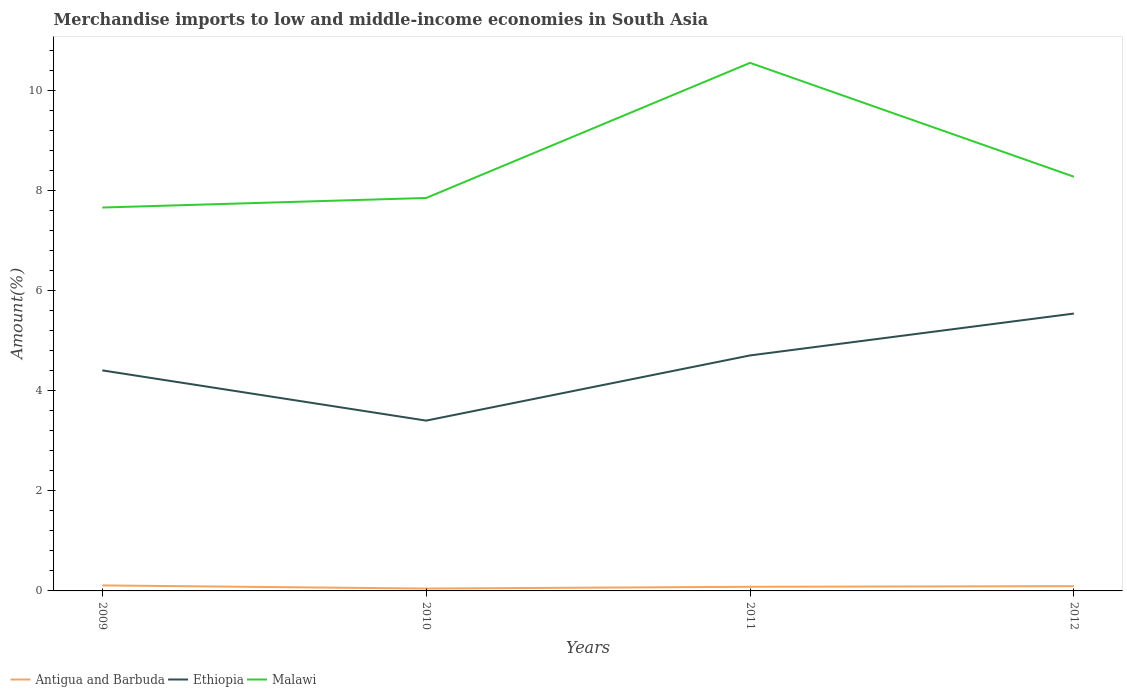How many different coloured lines are there?
Offer a very short reply. 3. Across all years, what is the maximum percentage of amount earned from merchandise imports in Ethiopia?
Your answer should be very brief. 3.41. What is the total percentage of amount earned from merchandise imports in Antigua and Barbuda in the graph?
Ensure brevity in your answer.  -0.04. What is the difference between the highest and the second highest percentage of amount earned from merchandise imports in Ethiopia?
Offer a very short reply. 2.14. What is the difference between the highest and the lowest percentage of amount earned from merchandise imports in Ethiopia?
Make the answer very short. 2. How many lines are there?
Provide a succinct answer. 3. Are the values on the major ticks of Y-axis written in scientific E-notation?
Give a very brief answer. No. Does the graph contain any zero values?
Your response must be concise. No. How are the legend labels stacked?
Your response must be concise. Horizontal. What is the title of the graph?
Make the answer very short. Merchandise imports to low and middle-income economies in South Asia. What is the label or title of the X-axis?
Offer a very short reply. Years. What is the label or title of the Y-axis?
Give a very brief answer. Amount(%). What is the Amount(%) in Antigua and Barbuda in 2009?
Give a very brief answer. 0.11. What is the Amount(%) of Ethiopia in 2009?
Your answer should be compact. 4.41. What is the Amount(%) in Malawi in 2009?
Provide a short and direct response. 7.67. What is the Amount(%) of Antigua and Barbuda in 2010?
Your answer should be very brief. 0.05. What is the Amount(%) of Ethiopia in 2010?
Give a very brief answer. 3.41. What is the Amount(%) of Malawi in 2010?
Ensure brevity in your answer.  7.86. What is the Amount(%) of Antigua and Barbuda in 2011?
Provide a succinct answer. 0.08. What is the Amount(%) of Ethiopia in 2011?
Provide a short and direct response. 4.71. What is the Amount(%) in Malawi in 2011?
Keep it short and to the point. 10.56. What is the Amount(%) in Antigua and Barbuda in 2012?
Ensure brevity in your answer.  0.09. What is the Amount(%) of Ethiopia in 2012?
Make the answer very short. 5.55. What is the Amount(%) of Malawi in 2012?
Your answer should be very brief. 8.28. Across all years, what is the maximum Amount(%) of Antigua and Barbuda?
Give a very brief answer. 0.11. Across all years, what is the maximum Amount(%) in Ethiopia?
Offer a terse response. 5.55. Across all years, what is the maximum Amount(%) of Malawi?
Your response must be concise. 10.56. Across all years, what is the minimum Amount(%) in Antigua and Barbuda?
Make the answer very short. 0.05. Across all years, what is the minimum Amount(%) in Ethiopia?
Offer a terse response. 3.41. Across all years, what is the minimum Amount(%) in Malawi?
Provide a succinct answer. 7.67. What is the total Amount(%) of Antigua and Barbuda in the graph?
Keep it short and to the point. 0.34. What is the total Amount(%) of Ethiopia in the graph?
Keep it short and to the point. 18.07. What is the total Amount(%) in Malawi in the graph?
Offer a very short reply. 34.36. What is the difference between the Amount(%) in Antigua and Barbuda in 2009 and that in 2010?
Offer a terse response. 0.06. What is the difference between the Amount(%) of Malawi in 2009 and that in 2010?
Give a very brief answer. -0.19. What is the difference between the Amount(%) in Antigua and Barbuda in 2009 and that in 2011?
Your answer should be compact. 0.03. What is the difference between the Amount(%) of Ethiopia in 2009 and that in 2011?
Your answer should be compact. -0.3. What is the difference between the Amount(%) of Malawi in 2009 and that in 2011?
Ensure brevity in your answer.  -2.89. What is the difference between the Amount(%) of Antigua and Barbuda in 2009 and that in 2012?
Keep it short and to the point. 0.02. What is the difference between the Amount(%) in Ethiopia in 2009 and that in 2012?
Provide a short and direct response. -1.14. What is the difference between the Amount(%) in Malawi in 2009 and that in 2012?
Your response must be concise. -0.62. What is the difference between the Amount(%) in Antigua and Barbuda in 2010 and that in 2011?
Make the answer very short. -0.04. What is the difference between the Amount(%) of Ethiopia in 2010 and that in 2011?
Provide a short and direct response. -1.3. What is the difference between the Amount(%) of Malawi in 2010 and that in 2011?
Make the answer very short. -2.7. What is the difference between the Amount(%) in Antigua and Barbuda in 2010 and that in 2012?
Provide a succinct answer. -0.05. What is the difference between the Amount(%) of Ethiopia in 2010 and that in 2012?
Ensure brevity in your answer.  -2.14. What is the difference between the Amount(%) of Malawi in 2010 and that in 2012?
Ensure brevity in your answer.  -0.42. What is the difference between the Amount(%) in Antigua and Barbuda in 2011 and that in 2012?
Offer a terse response. -0.01. What is the difference between the Amount(%) in Ethiopia in 2011 and that in 2012?
Your answer should be compact. -0.84. What is the difference between the Amount(%) of Malawi in 2011 and that in 2012?
Provide a short and direct response. 2.28. What is the difference between the Amount(%) in Antigua and Barbuda in 2009 and the Amount(%) in Ethiopia in 2010?
Offer a terse response. -3.3. What is the difference between the Amount(%) of Antigua and Barbuda in 2009 and the Amount(%) of Malawi in 2010?
Your response must be concise. -7.75. What is the difference between the Amount(%) of Ethiopia in 2009 and the Amount(%) of Malawi in 2010?
Offer a terse response. -3.45. What is the difference between the Amount(%) of Antigua and Barbuda in 2009 and the Amount(%) of Ethiopia in 2011?
Your answer should be compact. -4.6. What is the difference between the Amount(%) in Antigua and Barbuda in 2009 and the Amount(%) in Malawi in 2011?
Your answer should be very brief. -10.45. What is the difference between the Amount(%) of Ethiopia in 2009 and the Amount(%) of Malawi in 2011?
Ensure brevity in your answer.  -6.15. What is the difference between the Amount(%) of Antigua and Barbuda in 2009 and the Amount(%) of Ethiopia in 2012?
Give a very brief answer. -5.44. What is the difference between the Amount(%) of Antigua and Barbuda in 2009 and the Amount(%) of Malawi in 2012?
Provide a short and direct response. -8.17. What is the difference between the Amount(%) in Ethiopia in 2009 and the Amount(%) in Malawi in 2012?
Your response must be concise. -3.87. What is the difference between the Amount(%) of Antigua and Barbuda in 2010 and the Amount(%) of Ethiopia in 2011?
Offer a very short reply. -4.66. What is the difference between the Amount(%) of Antigua and Barbuda in 2010 and the Amount(%) of Malawi in 2011?
Keep it short and to the point. -10.51. What is the difference between the Amount(%) of Ethiopia in 2010 and the Amount(%) of Malawi in 2011?
Your answer should be compact. -7.15. What is the difference between the Amount(%) of Antigua and Barbuda in 2010 and the Amount(%) of Ethiopia in 2012?
Offer a very short reply. -5.5. What is the difference between the Amount(%) in Antigua and Barbuda in 2010 and the Amount(%) in Malawi in 2012?
Give a very brief answer. -8.23. What is the difference between the Amount(%) in Ethiopia in 2010 and the Amount(%) in Malawi in 2012?
Provide a short and direct response. -4.88. What is the difference between the Amount(%) of Antigua and Barbuda in 2011 and the Amount(%) of Ethiopia in 2012?
Your answer should be very brief. -5.46. What is the difference between the Amount(%) of Antigua and Barbuda in 2011 and the Amount(%) of Malawi in 2012?
Your answer should be compact. -8.2. What is the difference between the Amount(%) of Ethiopia in 2011 and the Amount(%) of Malawi in 2012?
Offer a terse response. -3.57. What is the average Amount(%) in Antigua and Barbuda per year?
Make the answer very short. 0.08. What is the average Amount(%) in Ethiopia per year?
Ensure brevity in your answer.  4.52. What is the average Amount(%) in Malawi per year?
Make the answer very short. 8.59. In the year 2009, what is the difference between the Amount(%) of Antigua and Barbuda and Amount(%) of Ethiopia?
Make the answer very short. -4.3. In the year 2009, what is the difference between the Amount(%) in Antigua and Barbuda and Amount(%) in Malawi?
Your answer should be very brief. -7.56. In the year 2009, what is the difference between the Amount(%) in Ethiopia and Amount(%) in Malawi?
Your response must be concise. -3.26. In the year 2010, what is the difference between the Amount(%) of Antigua and Barbuda and Amount(%) of Ethiopia?
Provide a short and direct response. -3.36. In the year 2010, what is the difference between the Amount(%) of Antigua and Barbuda and Amount(%) of Malawi?
Provide a short and direct response. -7.81. In the year 2010, what is the difference between the Amount(%) of Ethiopia and Amount(%) of Malawi?
Offer a terse response. -4.45. In the year 2011, what is the difference between the Amount(%) of Antigua and Barbuda and Amount(%) of Ethiopia?
Your response must be concise. -4.63. In the year 2011, what is the difference between the Amount(%) of Antigua and Barbuda and Amount(%) of Malawi?
Provide a succinct answer. -10.48. In the year 2011, what is the difference between the Amount(%) in Ethiopia and Amount(%) in Malawi?
Your answer should be compact. -5.85. In the year 2012, what is the difference between the Amount(%) of Antigua and Barbuda and Amount(%) of Ethiopia?
Ensure brevity in your answer.  -5.45. In the year 2012, what is the difference between the Amount(%) in Antigua and Barbuda and Amount(%) in Malawi?
Your answer should be compact. -8.19. In the year 2012, what is the difference between the Amount(%) of Ethiopia and Amount(%) of Malawi?
Offer a terse response. -2.74. What is the ratio of the Amount(%) of Antigua and Barbuda in 2009 to that in 2010?
Your answer should be very brief. 2.34. What is the ratio of the Amount(%) of Ethiopia in 2009 to that in 2010?
Offer a terse response. 1.29. What is the ratio of the Amount(%) in Malawi in 2009 to that in 2010?
Your answer should be very brief. 0.98. What is the ratio of the Amount(%) of Antigua and Barbuda in 2009 to that in 2011?
Your response must be concise. 1.33. What is the ratio of the Amount(%) in Ethiopia in 2009 to that in 2011?
Provide a short and direct response. 0.94. What is the ratio of the Amount(%) of Malawi in 2009 to that in 2011?
Offer a terse response. 0.73. What is the ratio of the Amount(%) in Antigua and Barbuda in 2009 to that in 2012?
Make the answer very short. 1.16. What is the ratio of the Amount(%) of Ethiopia in 2009 to that in 2012?
Your answer should be compact. 0.8. What is the ratio of the Amount(%) in Malawi in 2009 to that in 2012?
Offer a terse response. 0.93. What is the ratio of the Amount(%) of Antigua and Barbuda in 2010 to that in 2011?
Your response must be concise. 0.57. What is the ratio of the Amount(%) in Ethiopia in 2010 to that in 2011?
Provide a succinct answer. 0.72. What is the ratio of the Amount(%) in Malawi in 2010 to that in 2011?
Give a very brief answer. 0.74. What is the ratio of the Amount(%) in Antigua and Barbuda in 2010 to that in 2012?
Offer a very short reply. 0.5. What is the ratio of the Amount(%) of Ethiopia in 2010 to that in 2012?
Your answer should be very brief. 0.61. What is the ratio of the Amount(%) in Malawi in 2010 to that in 2012?
Ensure brevity in your answer.  0.95. What is the ratio of the Amount(%) in Antigua and Barbuda in 2011 to that in 2012?
Your answer should be compact. 0.87. What is the ratio of the Amount(%) of Ethiopia in 2011 to that in 2012?
Offer a terse response. 0.85. What is the ratio of the Amount(%) in Malawi in 2011 to that in 2012?
Offer a very short reply. 1.27. What is the difference between the highest and the second highest Amount(%) in Antigua and Barbuda?
Make the answer very short. 0.02. What is the difference between the highest and the second highest Amount(%) of Ethiopia?
Provide a short and direct response. 0.84. What is the difference between the highest and the second highest Amount(%) of Malawi?
Your response must be concise. 2.28. What is the difference between the highest and the lowest Amount(%) of Antigua and Barbuda?
Ensure brevity in your answer.  0.06. What is the difference between the highest and the lowest Amount(%) of Ethiopia?
Keep it short and to the point. 2.14. What is the difference between the highest and the lowest Amount(%) of Malawi?
Your answer should be very brief. 2.89. 